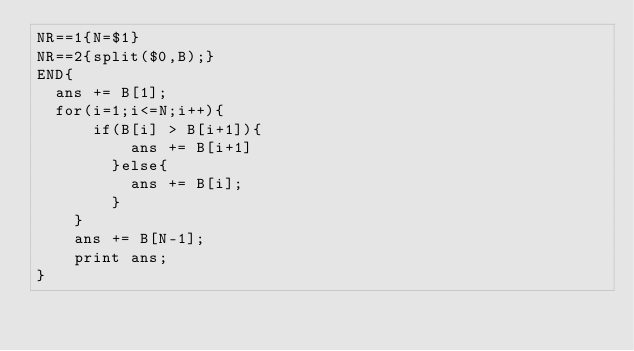Convert code to text. <code><loc_0><loc_0><loc_500><loc_500><_Awk_>NR==1{N=$1}
NR==2{split($0,B);}
END{
	ans += B[1];
	for(i=1;i<=N;i++){
    	if(B[i] > B[i+1]){
        	ans += B[i+1]
        }else{
        	ans += B[i];
        }
    }
    ans += B[N-1];
    print ans;
}</code> 